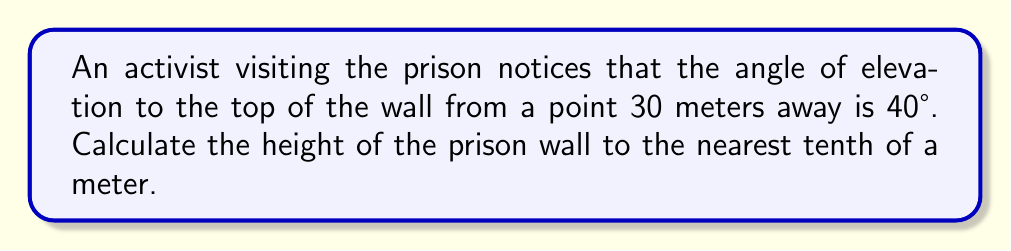Teach me how to tackle this problem. Let's approach this step-by-step:

1) We can visualize this as a right triangle, where:
   - The base is the distance from the activist to the wall (30 meters)
   - The height is the prison wall (what we're solving for)
   - The angle of elevation is 40°

2) In this right triangle, we know:
   - The adjacent side (30 meters)
   - The angle (40°)
   - We need to find the opposite side (wall height)

3) This scenario calls for the tangent ratio:

   $$\tan \theta = \frac{\text{opposite}}{\text{adjacent}}$$

4) Plugging in our known values:

   $$\tan 40° = \frac{\text{wall height}}{30}$$

5) To solve for the wall height, we multiply both sides by 30:

   $$30 \cdot \tan 40° = \text{wall height}$$

6) Now we can calculate:
   
   $$\text{wall height} = 30 \cdot \tan 40° \approx 30 \cdot 0.8391 \approx 25.173\text{ meters}$$

7) Rounding to the nearest tenth:

   $$\text{wall height} \approx 25.2\text{ meters}$$
Answer: $25.2\text{ meters}$ 